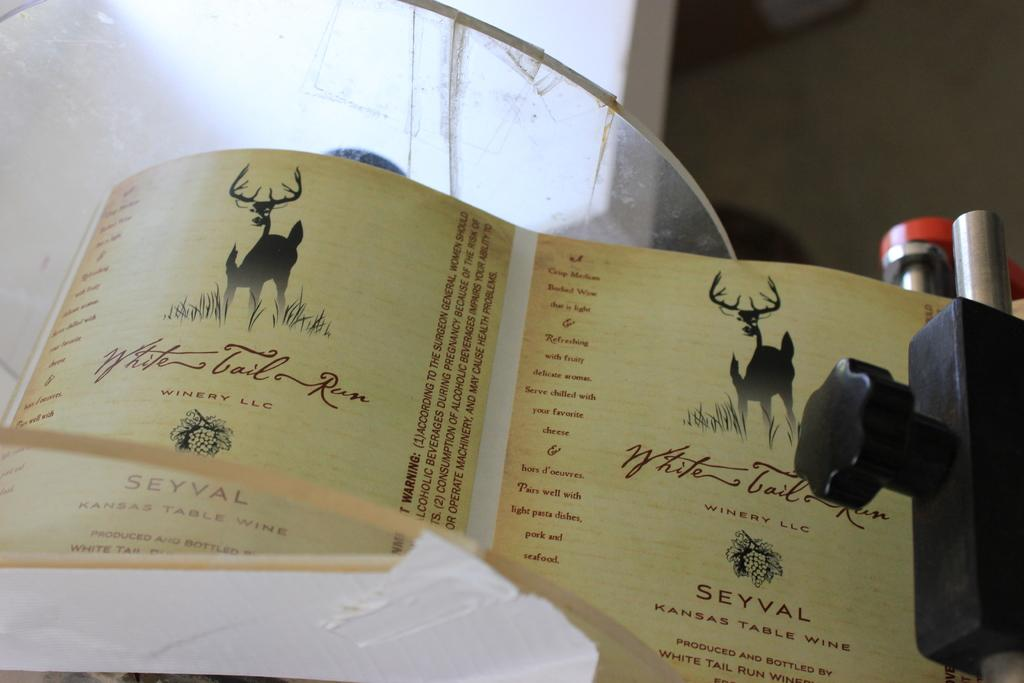What is on the paper that is visible in the image? There are pictures and text on the paper in the image. Where is the paper located in the image? The paper is placed on a surface in the image. What can be seen on the right side of the image? There are devices on the right side of the image. What type of prose is being read aloud from the paper in the image? There is no indication in the image that the paper contains prose or that it is being read aloud. 